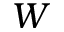<formula> <loc_0><loc_0><loc_500><loc_500>W</formula> 